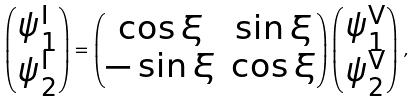<formula> <loc_0><loc_0><loc_500><loc_500>\begin{pmatrix} \psi ^ { \text {I} } _ { 1 } \\ \psi ^ { \text {I} } _ { 2 } \end{pmatrix} = \begin{pmatrix} \cos \xi & \sin \xi \\ - \sin \xi & \cos \xi \end{pmatrix} \begin{pmatrix} \psi ^ { \text {V} } _ { 1 } \\ \psi ^ { \text {V} } _ { 2 } \end{pmatrix} \, ,</formula> 